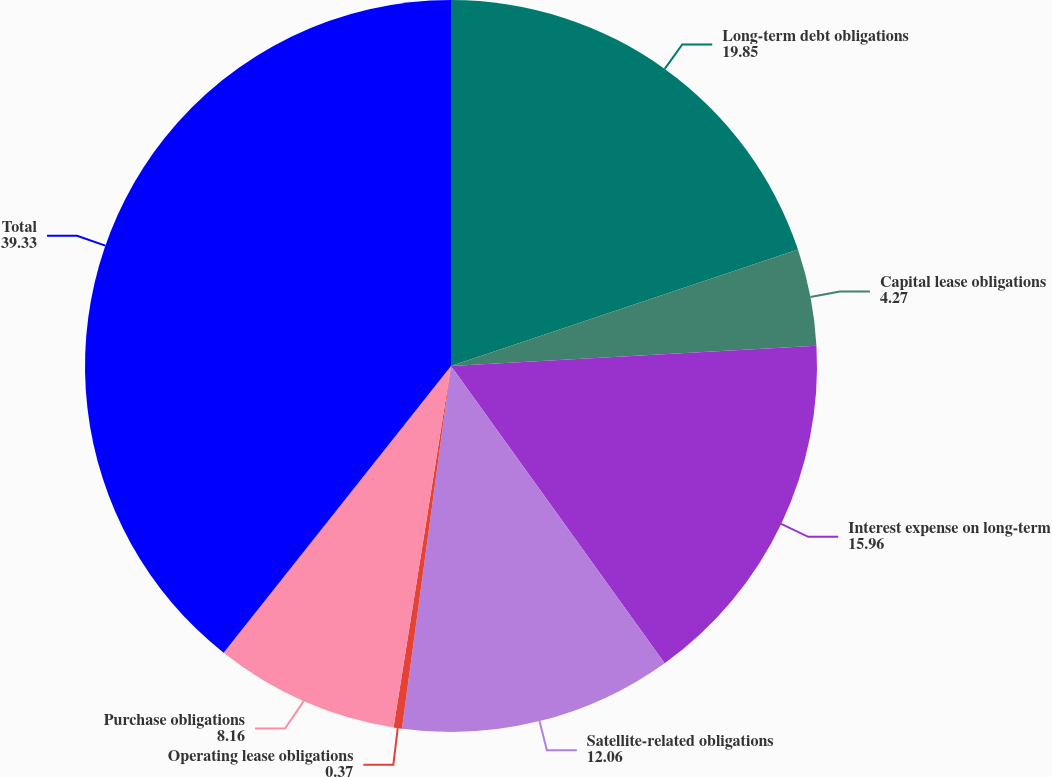Convert chart. <chart><loc_0><loc_0><loc_500><loc_500><pie_chart><fcel>Long-term debt obligations<fcel>Capital lease obligations<fcel>Interest expense on long-term<fcel>Satellite-related obligations<fcel>Operating lease obligations<fcel>Purchase obligations<fcel>Total<nl><fcel>19.85%<fcel>4.27%<fcel>15.96%<fcel>12.06%<fcel>0.37%<fcel>8.16%<fcel>39.33%<nl></chart> 